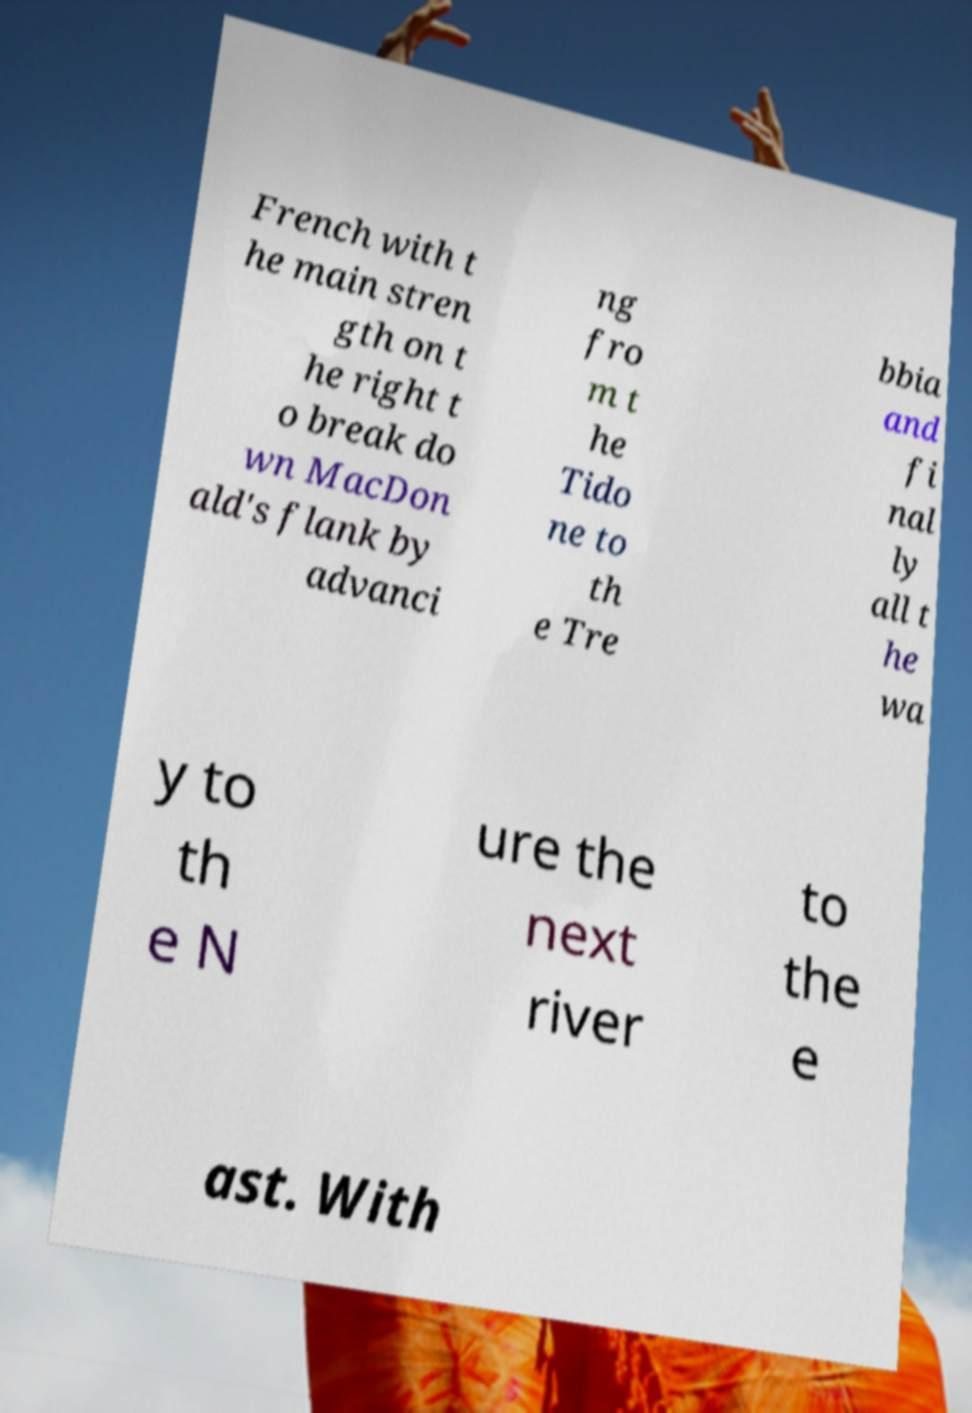There's text embedded in this image that I need extracted. Can you transcribe it verbatim? French with t he main stren gth on t he right t o break do wn MacDon ald's flank by advanci ng fro m t he Tido ne to th e Tre bbia and fi nal ly all t he wa y to th e N ure the next river to the e ast. With 